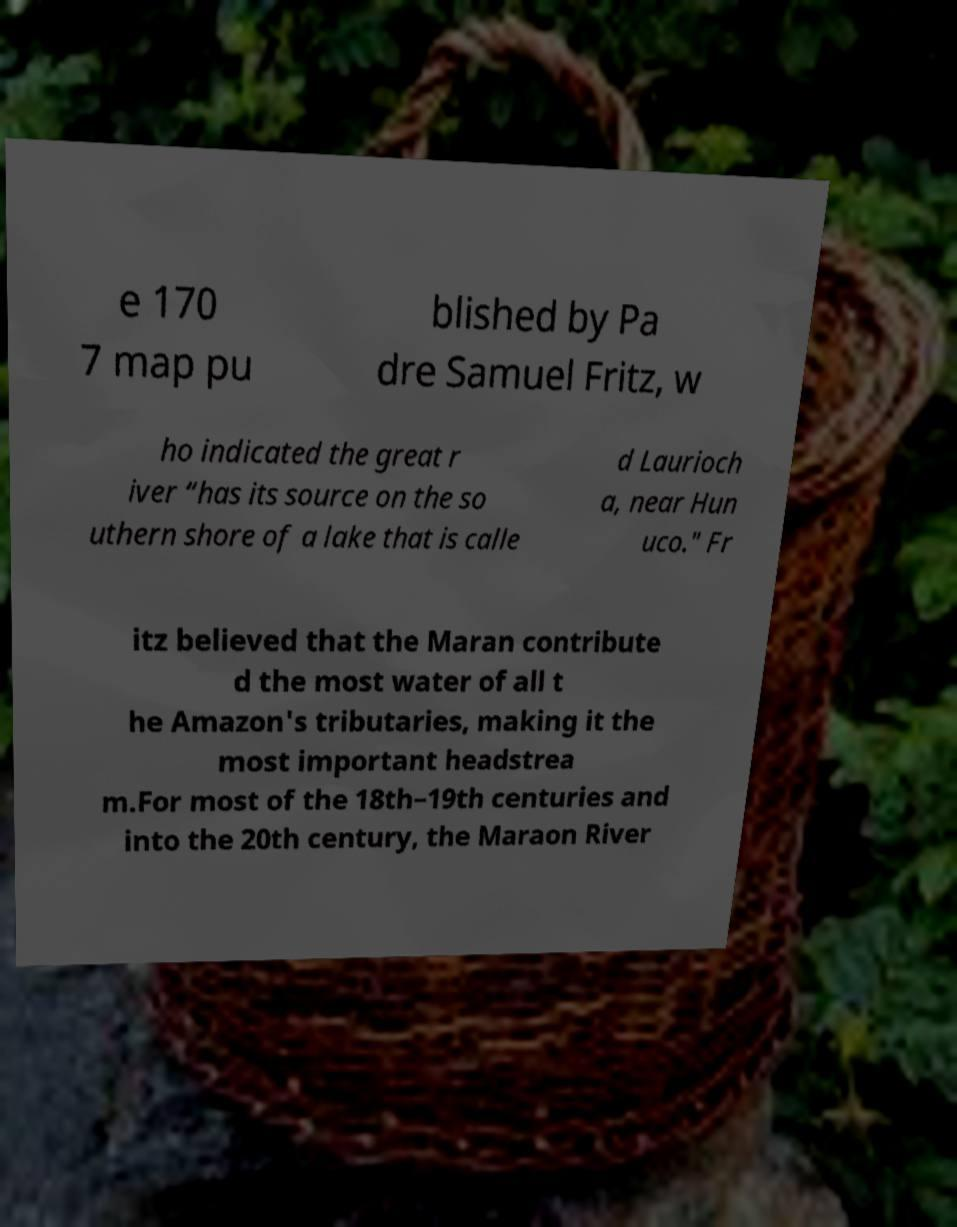Can you accurately transcribe the text from the provided image for me? e 170 7 map pu blished by Pa dre Samuel Fritz, w ho indicated the great r iver “has its source on the so uthern shore of a lake that is calle d Laurioch a, near Hun uco." Fr itz believed that the Maran contribute d the most water of all t he Amazon's tributaries, making it the most important headstrea m.For most of the 18th–19th centuries and into the 20th century, the Maraon River 